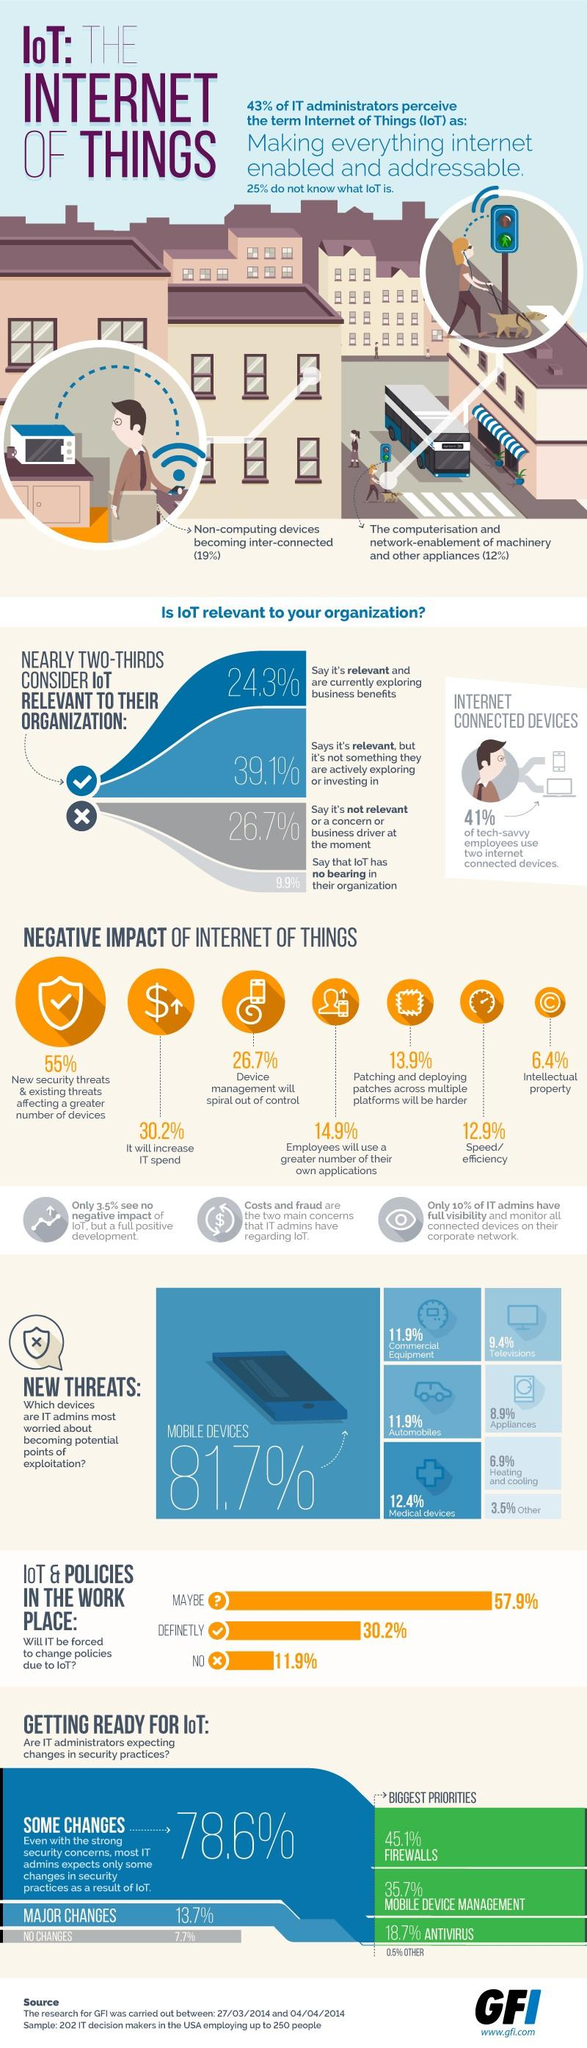Specify some key components in this picture. According to 11.9% of IT admins, commercial equipment and automobiles are perceived as threats to cybersecurity. Mobile device management is the second most important priority in security practices. According to a recent survey, a significant percentage of people, approximately 59%, do not use two or more internet-connected devices. According to the findings, a total of 63.4% of individuals believe that IoT is relevant, regardless of whether or not they are exploring it. 